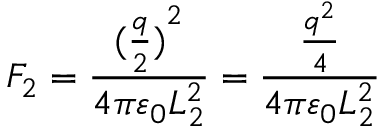<formula> <loc_0><loc_0><loc_500><loc_500>F _ { 2 } = { \frac { { ( { \frac { q } { 2 } } ) } ^ { 2 } } { 4 \pi \varepsilon _ { 0 } L _ { 2 } ^ { 2 } } } = { \frac { \frac { q ^ { 2 } } { 4 } } { 4 \pi \varepsilon _ { 0 } L _ { 2 } ^ { 2 } } } \,</formula> 